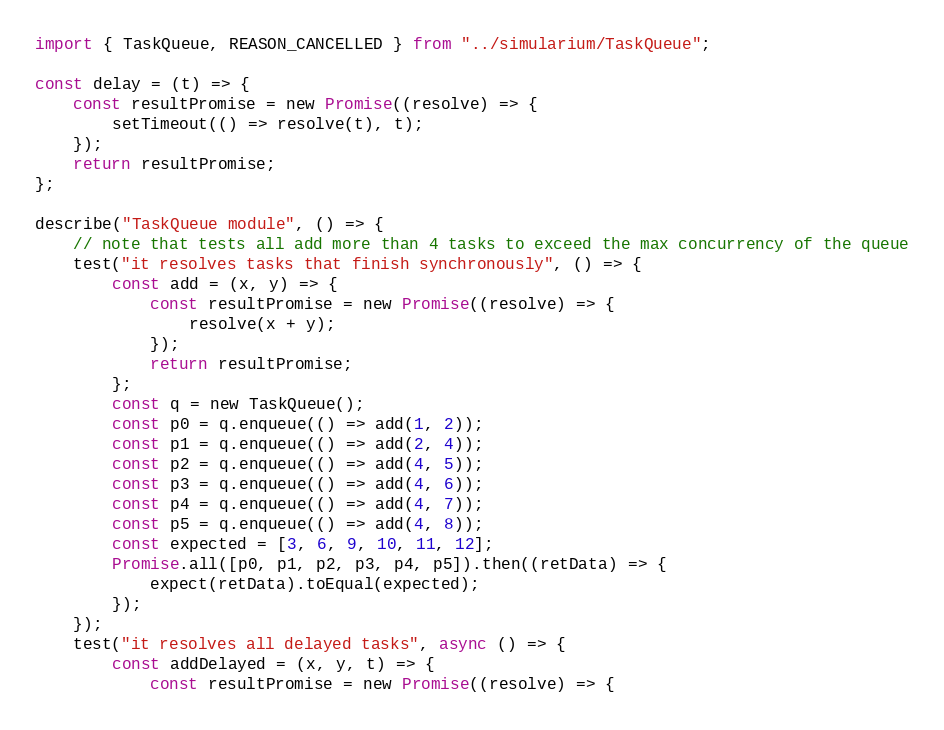<code> <loc_0><loc_0><loc_500><loc_500><_TypeScript_>import { TaskQueue, REASON_CANCELLED } from "../simularium/TaskQueue";

const delay = (t) => {
    const resultPromise = new Promise((resolve) => {
        setTimeout(() => resolve(t), t);
    });
    return resultPromise;
};

describe("TaskQueue module", () => {
    // note that tests all add more than 4 tasks to exceed the max concurrency of the queue
    test("it resolves tasks that finish synchronously", () => {
        const add = (x, y) => {
            const resultPromise = new Promise((resolve) => {
                resolve(x + y);
            });
            return resultPromise;
        };
        const q = new TaskQueue();
        const p0 = q.enqueue(() => add(1, 2));
        const p1 = q.enqueue(() => add(2, 4));
        const p2 = q.enqueue(() => add(4, 5));
        const p3 = q.enqueue(() => add(4, 6));
        const p4 = q.enqueue(() => add(4, 7));
        const p5 = q.enqueue(() => add(4, 8));
        const expected = [3, 6, 9, 10, 11, 12];
        Promise.all([p0, p1, p2, p3, p4, p5]).then((retData) => {
            expect(retData).toEqual(expected);
        });
    });
    test("it resolves all delayed tasks", async () => {
        const addDelayed = (x, y, t) => {
            const resultPromise = new Promise((resolve) => {</code> 